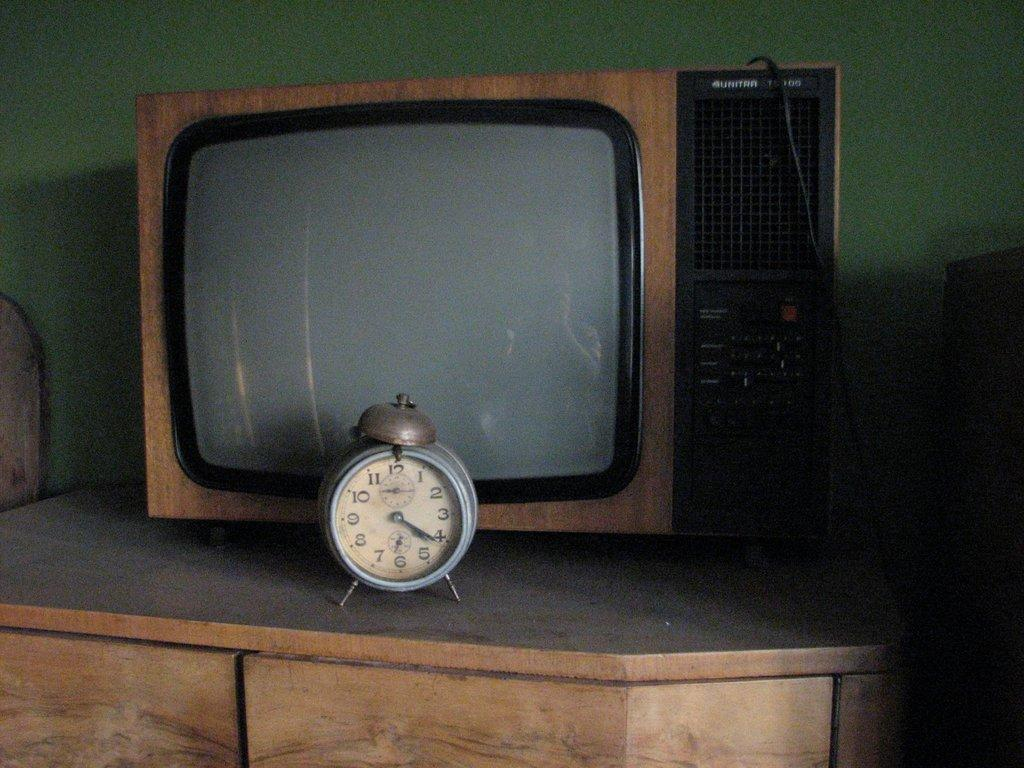<image>
Share a concise interpretation of the image provided. a small alarm clock on a dresser that reads '4:21' 